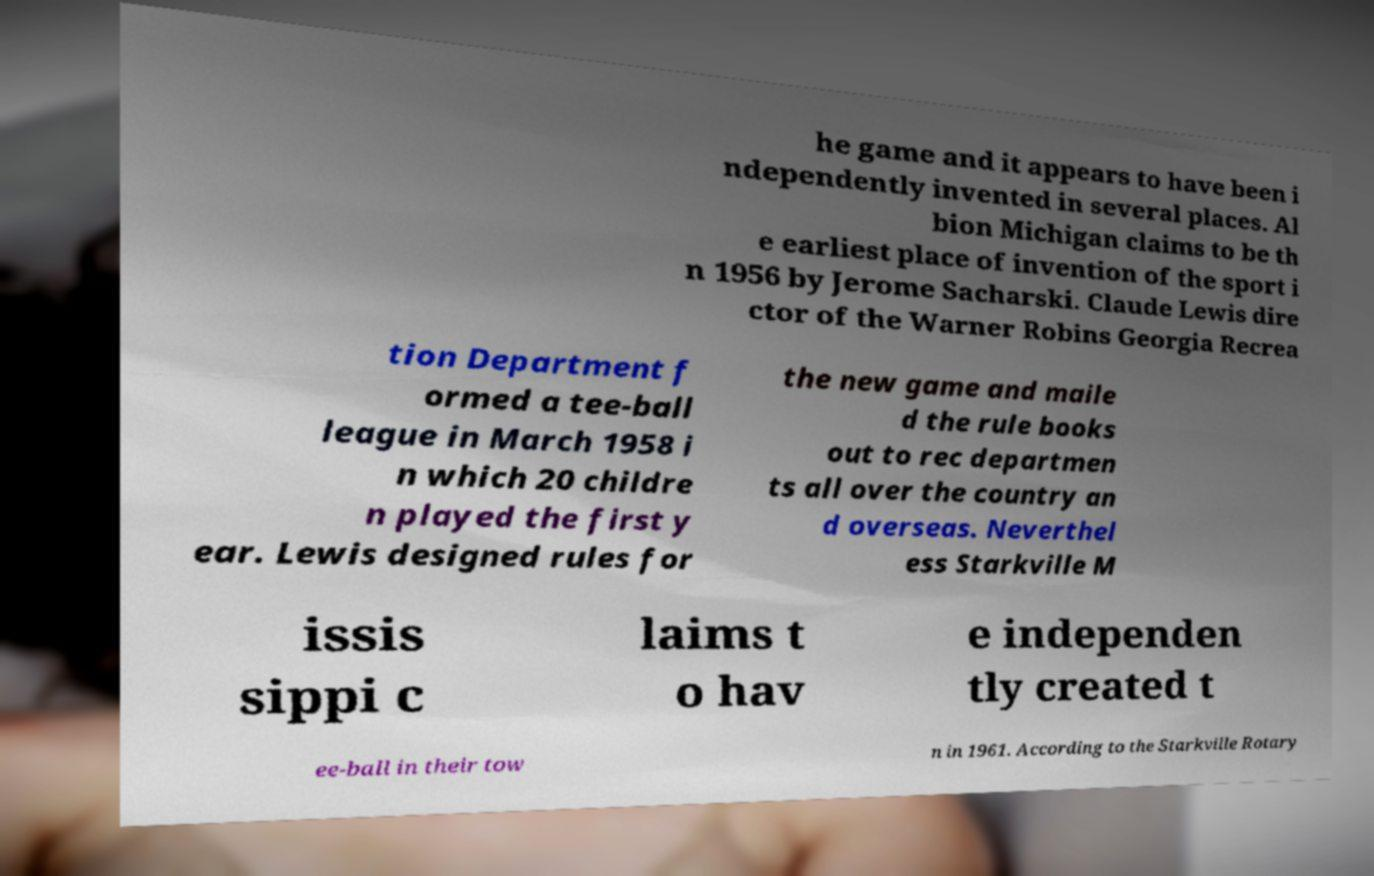I need the written content from this picture converted into text. Can you do that? he game and it appears to have been i ndependently invented in several places. Al bion Michigan claims to be th e earliest place of invention of the sport i n 1956 by Jerome Sacharski. Claude Lewis dire ctor of the Warner Robins Georgia Recrea tion Department f ormed a tee-ball league in March 1958 i n which 20 childre n played the first y ear. Lewis designed rules for the new game and maile d the rule books out to rec departmen ts all over the country an d overseas. Neverthel ess Starkville M issis sippi c laims t o hav e independen tly created t ee-ball in their tow n in 1961. According to the Starkville Rotary 